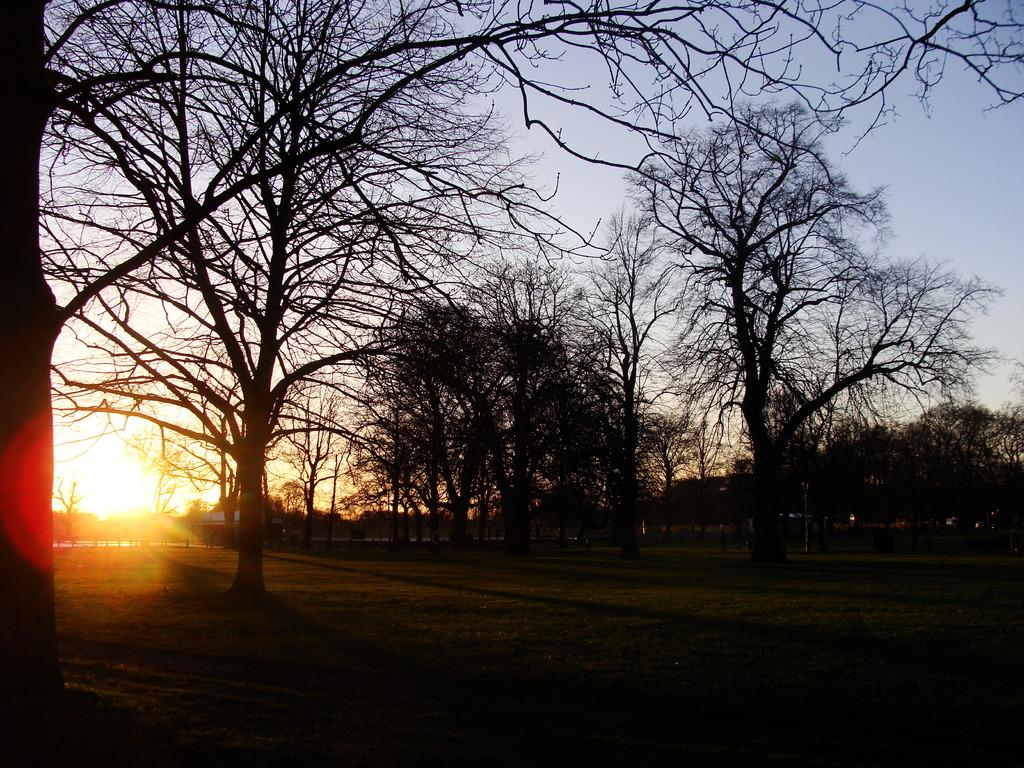What type of vegetation can be seen in the image? There are trees in the image. What is the source of light in the image? Sunlight is visible in the image. What else can be seen in the sky besides the trees? The sky is visible in the image. What type of brass instrument is being played in the image? There is no brass instrument or any musical instruments present in the image. How many clovers can be seen growing among the trees in the image? There are no clovers visible in the image; it only features trees, sunlight, and the sky. 